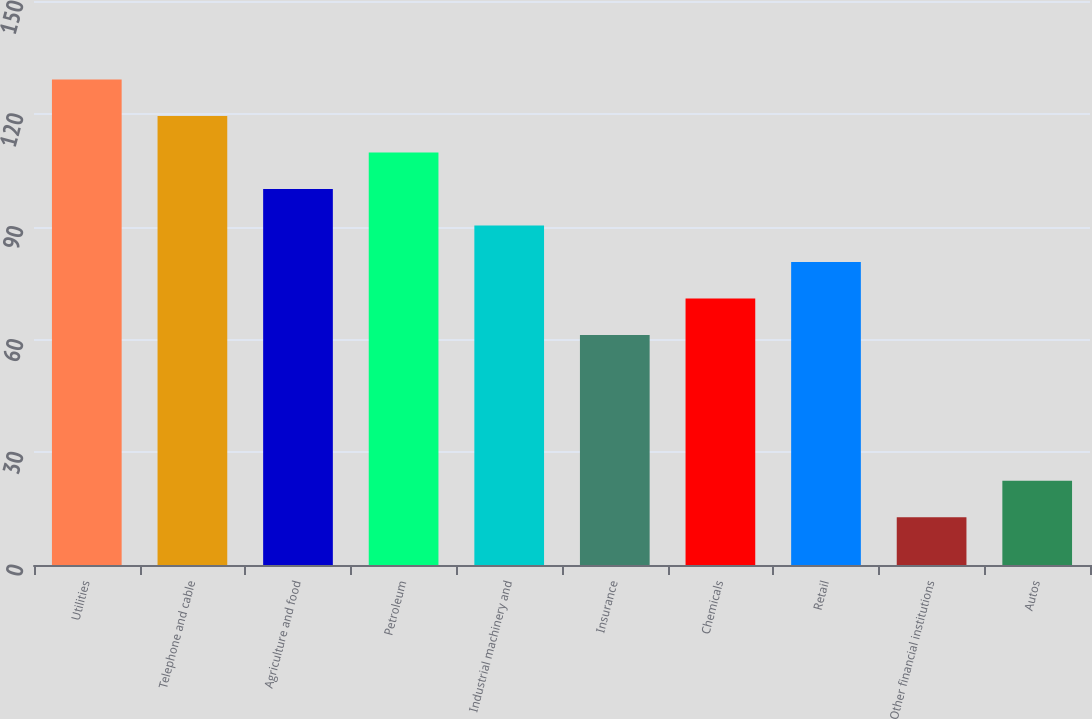<chart> <loc_0><loc_0><loc_500><loc_500><bar_chart><fcel>Utilities<fcel>Telephone and cable<fcel>Agriculture and food<fcel>Petroleum<fcel>Industrial machinery and<fcel>Insurance<fcel>Chemicals<fcel>Retail<fcel>Other financial institutions<fcel>Autos<nl><fcel>129.1<fcel>119.4<fcel>100<fcel>109.7<fcel>90.3<fcel>61.2<fcel>70.9<fcel>80.6<fcel>12.7<fcel>22.4<nl></chart> 